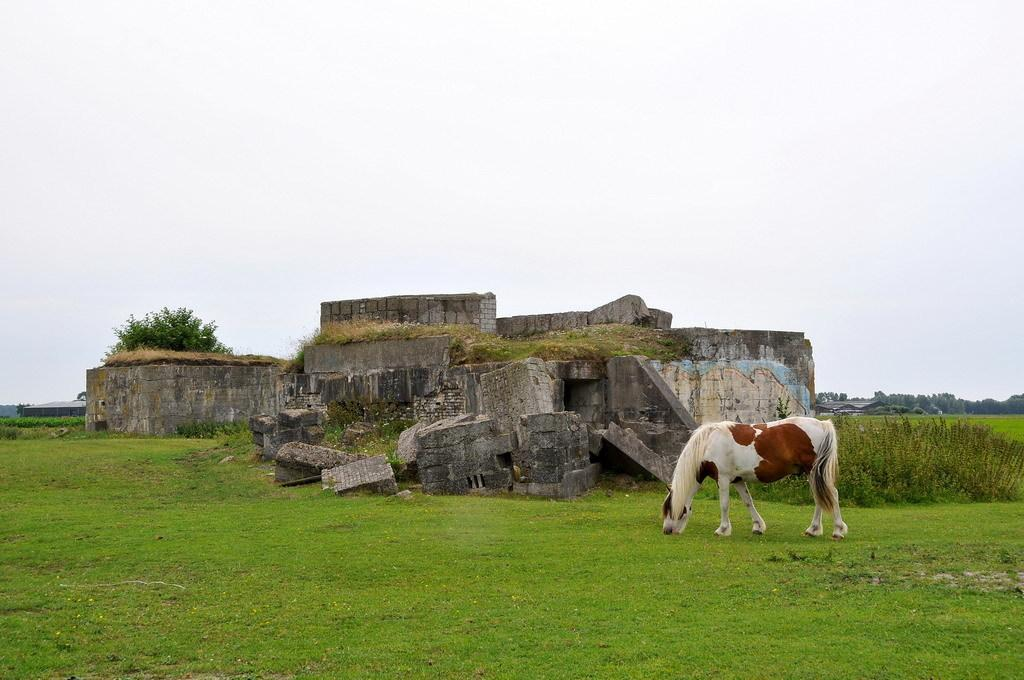What animal is present in the image? There is a horse in the image. What is the horse doing in the image? The horse is eating grass. What color is the ground in the image? The ground is green. What can be found beside the horse? There is an object beside the horse. What type of vegetation is visible in the image? There are trees in the right corner of the image. What type of sponge is being used to clean the horse's teeth in the image? There is no sponge or toothbrush present in the image, and the horse is not being cleaned or groomed. 